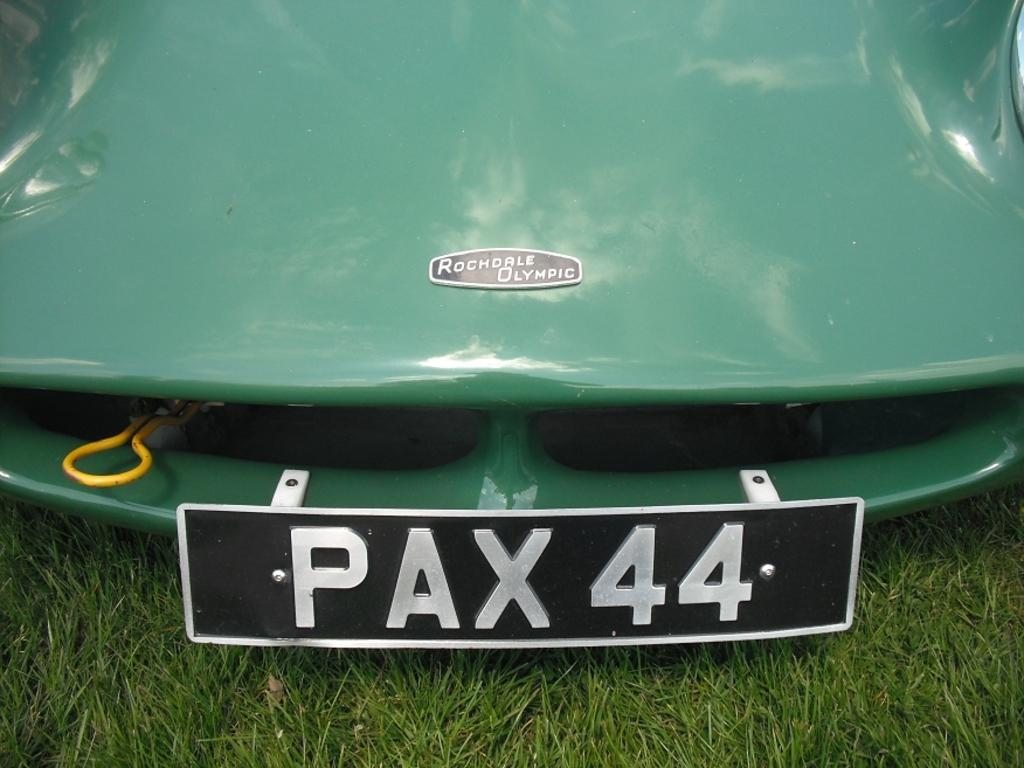<image>
Relay a brief, clear account of the picture shown. A license plate says "PAX 44" on the front of a car. 